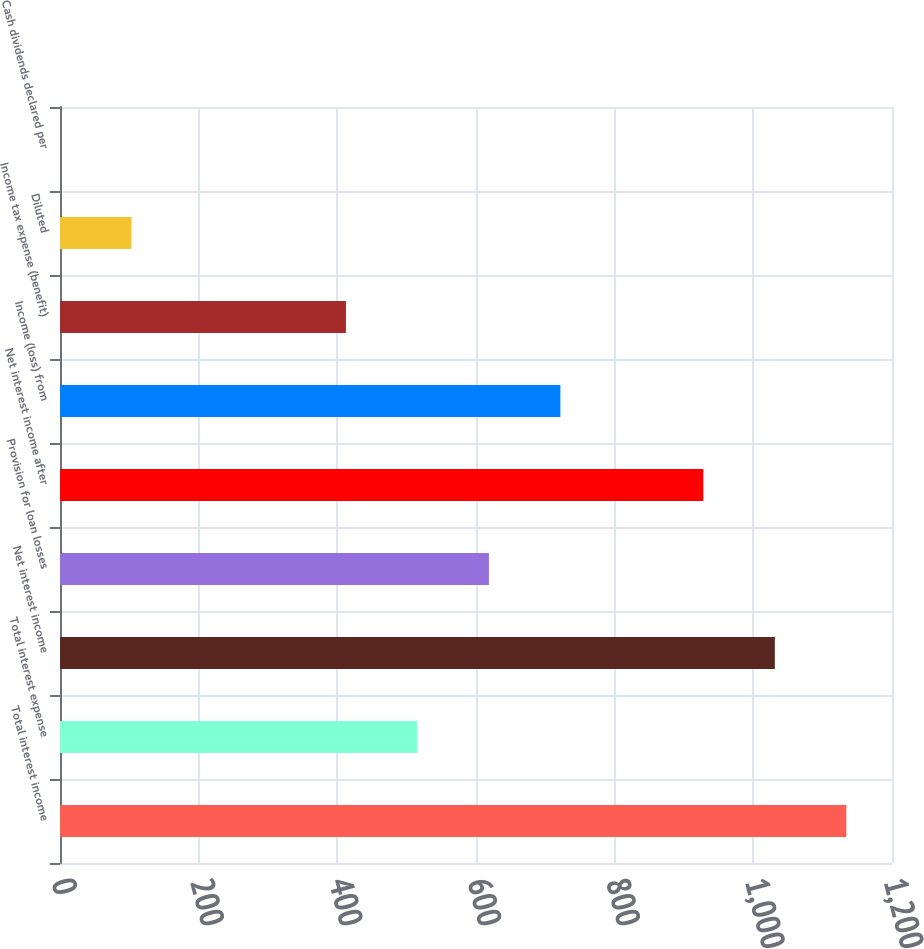<chart> <loc_0><loc_0><loc_500><loc_500><bar_chart><fcel>Total interest income<fcel>Total interest expense<fcel>Net interest income<fcel>Provision for loan losses<fcel>Net interest income after<fcel>Income (loss) from<fcel>Income tax expense (benefit)<fcel>Diluted<fcel>Cash dividends declared per<nl><fcel>1134.11<fcel>515.51<fcel>1031.01<fcel>618.61<fcel>927.91<fcel>721.71<fcel>412.41<fcel>103.11<fcel>0.01<nl></chart> 